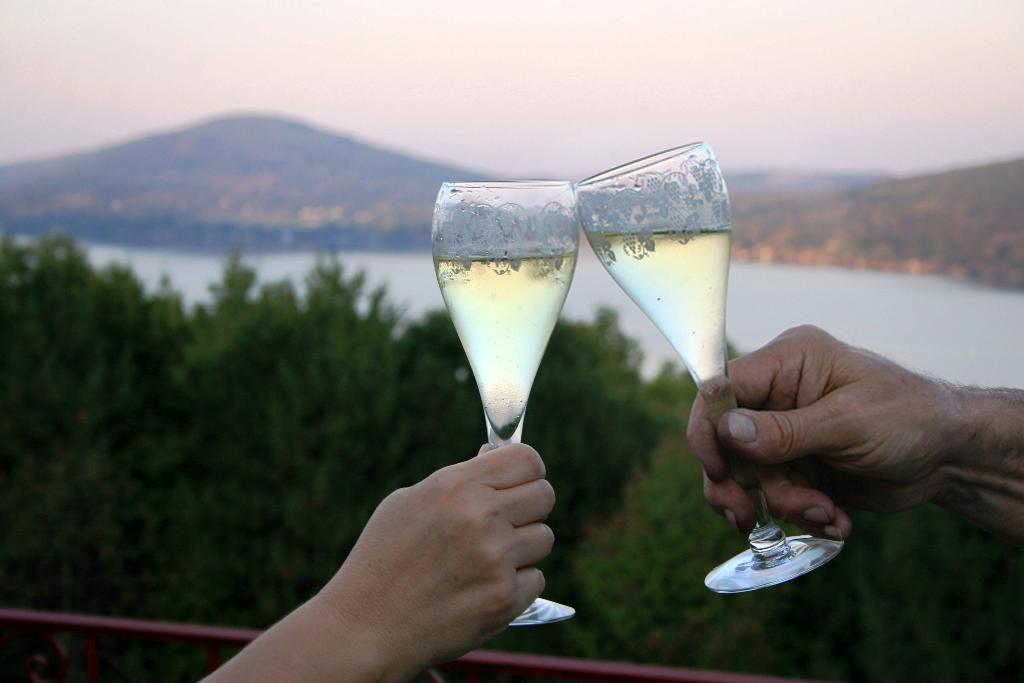What are the two persons holding in the image? The two persons are holding glasses with a drink in the image. What type of natural environment can be seen in the image? There are trees, water, and mountains visible in the image. What architectural feature is present in the image? There is a fence in the image. What part of the natural environment is visible in the image? The sky is visible in the image. What type of rail can be seen in the image? There is no rail present in the image. How many fingers does the person on the left have in the image? We cannot determine the number of fingers the person on the left has in the image, as the image does not provide a clear view of their hands. 